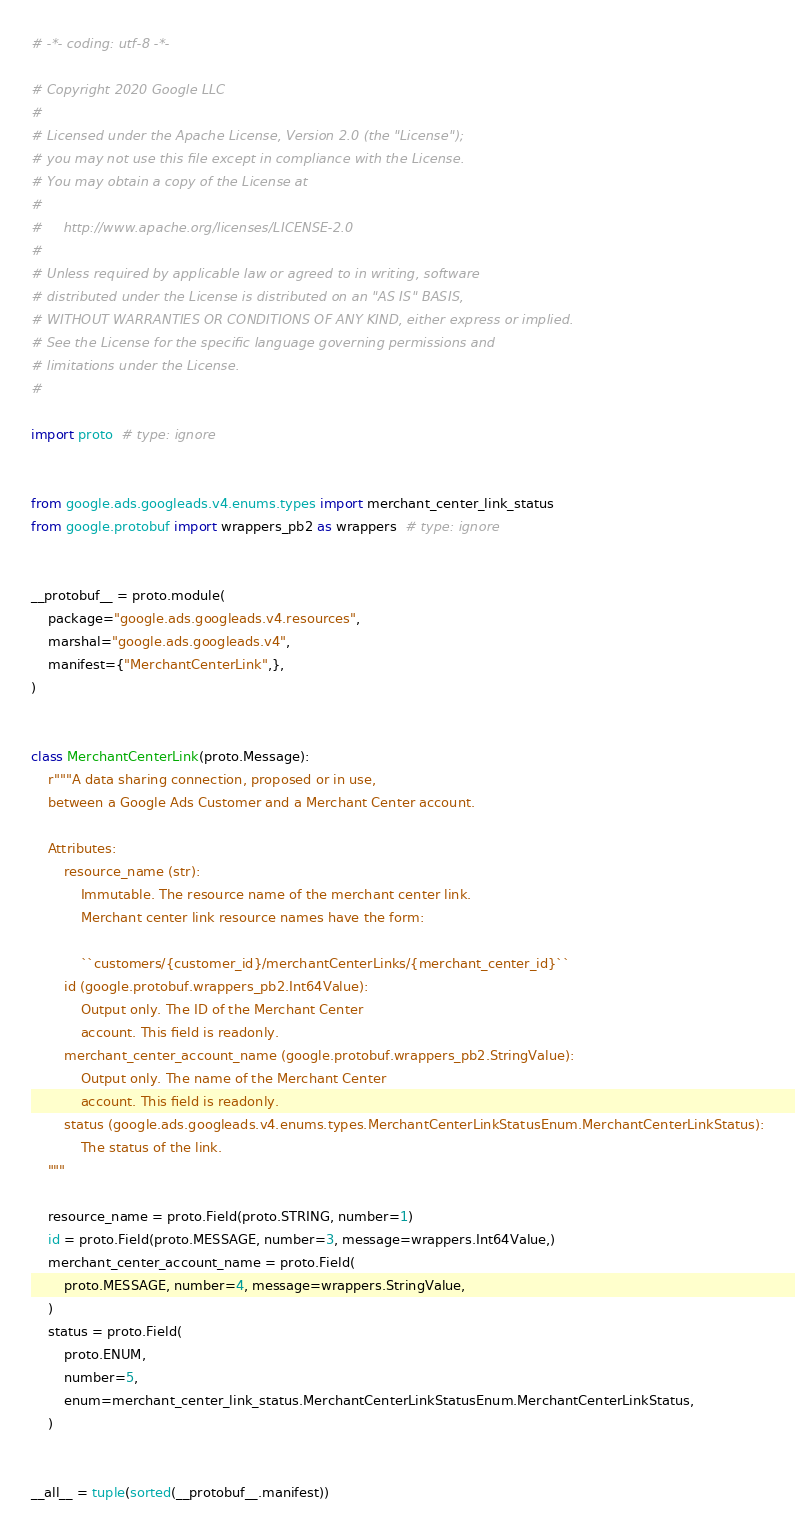<code> <loc_0><loc_0><loc_500><loc_500><_Python_># -*- coding: utf-8 -*-

# Copyright 2020 Google LLC
#
# Licensed under the Apache License, Version 2.0 (the "License");
# you may not use this file except in compliance with the License.
# You may obtain a copy of the License at
#
#     http://www.apache.org/licenses/LICENSE-2.0
#
# Unless required by applicable law or agreed to in writing, software
# distributed under the License is distributed on an "AS IS" BASIS,
# WITHOUT WARRANTIES OR CONDITIONS OF ANY KIND, either express or implied.
# See the License for the specific language governing permissions and
# limitations under the License.
#

import proto  # type: ignore


from google.ads.googleads.v4.enums.types import merchant_center_link_status
from google.protobuf import wrappers_pb2 as wrappers  # type: ignore


__protobuf__ = proto.module(
    package="google.ads.googleads.v4.resources",
    marshal="google.ads.googleads.v4",
    manifest={"MerchantCenterLink",},
)


class MerchantCenterLink(proto.Message):
    r"""A data sharing connection, proposed or in use,
    between a Google Ads Customer and a Merchant Center account.

    Attributes:
        resource_name (str):
            Immutable. The resource name of the merchant center link.
            Merchant center link resource names have the form:

            ``customers/{customer_id}/merchantCenterLinks/{merchant_center_id}``
        id (google.protobuf.wrappers_pb2.Int64Value):
            Output only. The ID of the Merchant Center
            account. This field is readonly.
        merchant_center_account_name (google.protobuf.wrappers_pb2.StringValue):
            Output only. The name of the Merchant Center
            account. This field is readonly.
        status (google.ads.googleads.v4.enums.types.MerchantCenterLinkStatusEnum.MerchantCenterLinkStatus):
            The status of the link.
    """

    resource_name = proto.Field(proto.STRING, number=1)
    id = proto.Field(proto.MESSAGE, number=3, message=wrappers.Int64Value,)
    merchant_center_account_name = proto.Field(
        proto.MESSAGE, number=4, message=wrappers.StringValue,
    )
    status = proto.Field(
        proto.ENUM,
        number=5,
        enum=merchant_center_link_status.MerchantCenterLinkStatusEnum.MerchantCenterLinkStatus,
    )


__all__ = tuple(sorted(__protobuf__.manifest))
</code> 